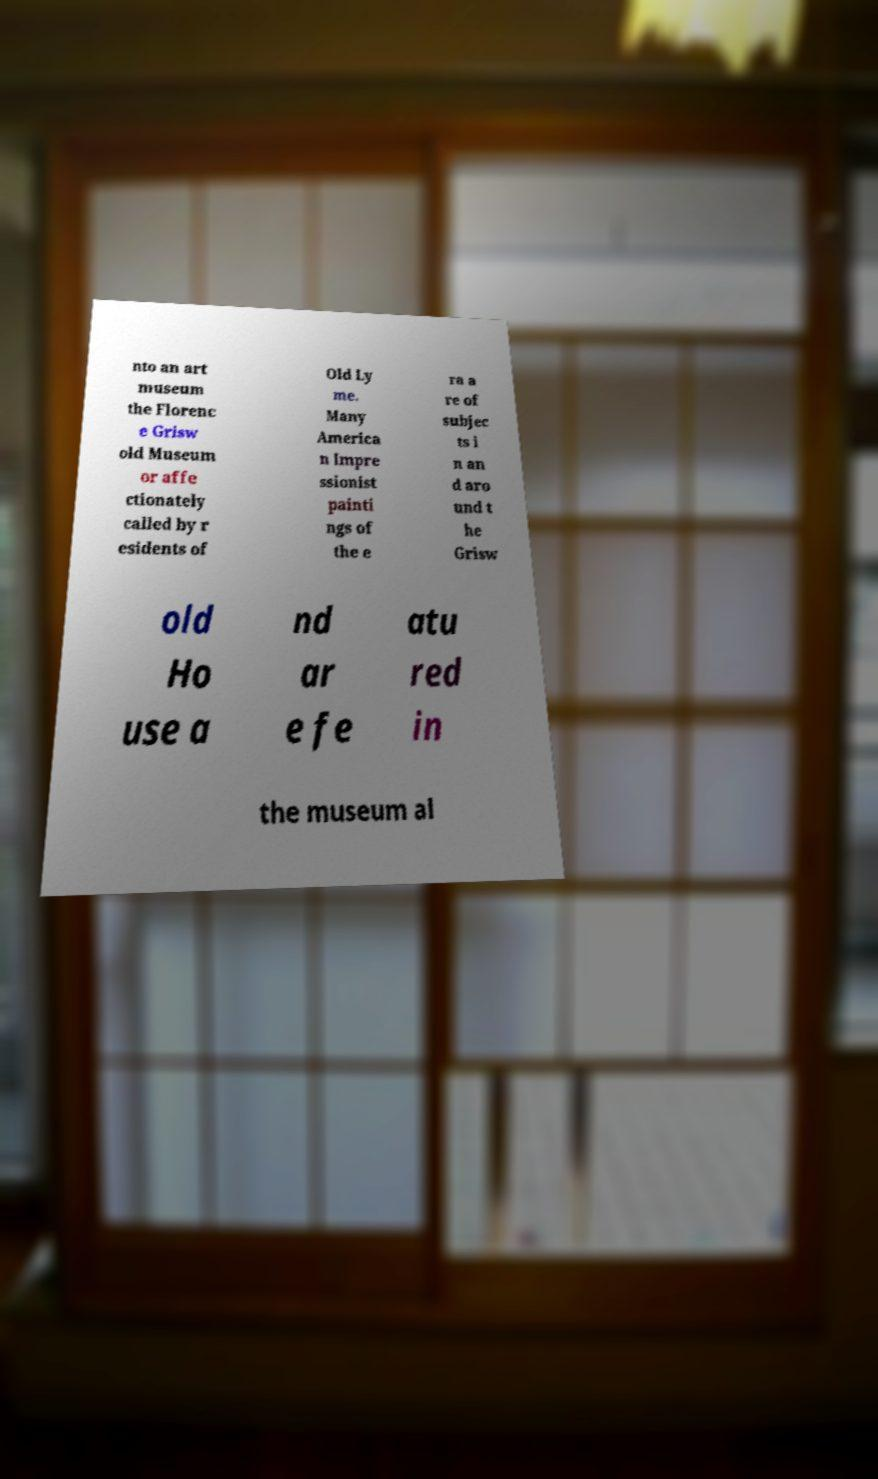Please read and relay the text visible in this image. What does it say? nto an art museum the Florenc e Grisw old Museum or affe ctionately called by r esidents of Old Ly me. Many America n Impre ssionist painti ngs of the e ra a re of subjec ts i n an d aro und t he Grisw old Ho use a nd ar e fe atu red in the museum al 